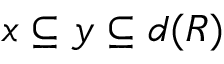Convert formula to latex. <formula><loc_0><loc_0><loc_500><loc_500>x \subseteq y \subseteq d ( R )</formula> 